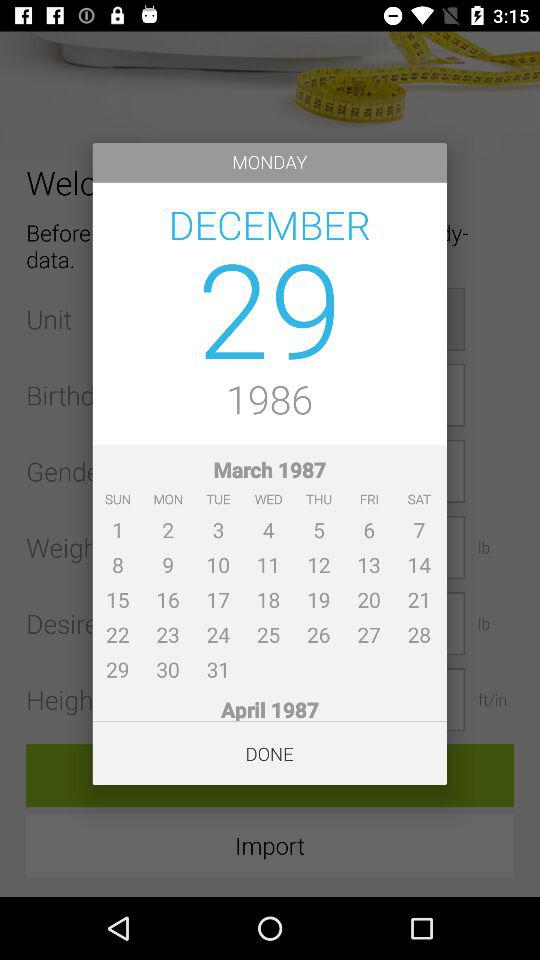Which day falls on December 29th, 1986? The day is Monday. 